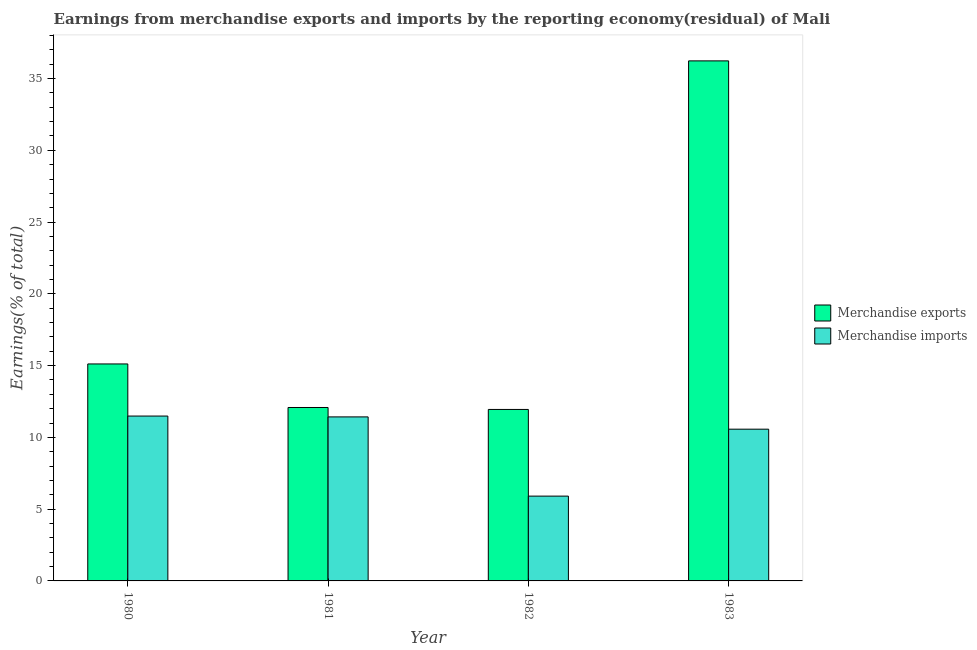How many groups of bars are there?
Make the answer very short. 4. Are the number of bars per tick equal to the number of legend labels?
Make the answer very short. Yes. Are the number of bars on each tick of the X-axis equal?
Your answer should be very brief. Yes. How many bars are there on the 1st tick from the right?
Ensure brevity in your answer.  2. In how many cases, is the number of bars for a given year not equal to the number of legend labels?
Ensure brevity in your answer.  0. What is the earnings from merchandise imports in 1983?
Give a very brief answer. 10.57. Across all years, what is the maximum earnings from merchandise exports?
Give a very brief answer. 36.23. Across all years, what is the minimum earnings from merchandise exports?
Keep it short and to the point. 11.95. In which year was the earnings from merchandise exports maximum?
Your answer should be compact. 1983. In which year was the earnings from merchandise exports minimum?
Provide a succinct answer. 1982. What is the total earnings from merchandise exports in the graph?
Offer a very short reply. 75.38. What is the difference between the earnings from merchandise imports in 1980 and that in 1983?
Offer a very short reply. 0.91. What is the difference between the earnings from merchandise imports in 1982 and the earnings from merchandise exports in 1983?
Your response must be concise. -4.66. What is the average earnings from merchandise imports per year?
Offer a very short reply. 9.85. In the year 1981, what is the difference between the earnings from merchandise exports and earnings from merchandise imports?
Offer a very short reply. 0. What is the ratio of the earnings from merchandise exports in 1980 to that in 1983?
Offer a very short reply. 0.42. Is the earnings from merchandise imports in 1981 less than that in 1983?
Your answer should be very brief. No. What is the difference between the highest and the second highest earnings from merchandise imports?
Provide a succinct answer. 0.06. What is the difference between the highest and the lowest earnings from merchandise exports?
Offer a very short reply. 24.28. In how many years, is the earnings from merchandise exports greater than the average earnings from merchandise exports taken over all years?
Keep it short and to the point. 1. What does the 1st bar from the left in 1980 represents?
Offer a very short reply. Merchandise exports. What does the 2nd bar from the right in 1983 represents?
Offer a very short reply. Merchandise exports. How many bars are there?
Provide a short and direct response. 8. Are all the bars in the graph horizontal?
Your answer should be very brief. No. How many years are there in the graph?
Your answer should be compact. 4. What is the difference between two consecutive major ticks on the Y-axis?
Your answer should be very brief. 5. Are the values on the major ticks of Y-axis written in scientific E-notation?
Provide a succinct answer. No. How are the legend labels stacked?
Provide a short and direct response. Vertical. What is the title of the graph?
Your answer should be compact. Earnings from merchandise exports and imports by the reporting economy(residual) of Mali. Does "Passenger Transport Items" appear as one of the legend labels in the graph?
Your answer should be very brief. No. What is the label or title of the X-axis?
Provide a succinct answer. Year. What is the label or title of the Y-axis?
Offer a terse response. Earnings(% of total). What is the Earnings(% of total) in Merchandise exports in 1980?
Ensure brevity in your answer.  15.12. What is the Earnings(% of total) in Merchandise imports in 1980?
Provide a short and direct response. 11.49. What is the Earnings(% of total) in Merchandise exports in 1981?
Offer a terse response. 12.08. What is the Earnings(% of total) of Merchandise imports in 1981?
Provide a succinct answer. 11.43. What is the Earnings(% of total) in Merchandise exports in 1982?
Offer a very short reply. 11.95. What is the Earnings(% of total) in Merchandise imports in 1982?
Make the answer very short. 5.91. What is the Earnings(% of total) in Merchandise exports in 1983?
Give a very brief answer. 36.23. What is the Earnings(% of total) in Merchandise imports in 1983?
Offer a terse response. 10.57. Across all years, what is the maximum Earnings(% of total) in Merchandise exports?
Offer a very short reply. 36.23. Across all years, what is the maximum Earnings(% of total) in Merchandise imports?
Your answer should be very brief. 11.49. Across all years, what is the minimum Earnings(% of total) in Merchandise exports?
Your response must be concise. 11.95. Across all years, what is the minimum Earnings(% of total) in Merchandise imports?
Your response must be concise. 5.91. What is the total Earnings(% of total) of Merchandise exports in the graph?
Provide a succinct answer. 75.38. What is the total Earnings(% of total) of Merchandise imports in the graph?
Provide a short and direct response. 39.39. What is the difference between the Earnings(% of total) in Merchandise exports in 1980 and that in 1981?
Keep it short and to the point. 3.03. What is the difference between the Earnings(% of total) in Merchandise imports in 1980 and that in 1981?
Your response must be concise. 0.06. What is the difference between the Earnings(% of total) in Merchandise exports in 1980 and that in 1982?
Ensure brevity in your answer.  3.17. What is the difference between the Earnings(% of total) of Merchandise imports in 1980 and that in 1982?
Your answer should be very brief. 5.58. What is the difference between the Earnings(% of total) in Merchandise exports in 1980 and that in 1983?
Your response must be concise. -21.11. What is the difference between the Earnings(% of total) in Merchandise imports in 1980 and that in 1983?
Offer a terse response. 0.91. What is the difference between the Earnings(% of total) of Merchandise exports in 1981 and that in 1982?
Give a very brief answer. 0.14. What is the difference between the Earnings(% of total) in Merchandise imports in 1981 and that in 1982?
Your answer should be compact. 5.52. What is the difference between the Earnings(% of total) of Merchandise exports in 1981 and that in 1983?
Your answer should be very brief. -24.15. What is the difference between the Earnings(% of total) in Merchandise imports in 1981 and that in 1983?
Offer a terse response. 0.86. What is the difference between the Earnings(% of total) in Merchandise exports in 1982 and that in 1983?
Give a very brief answer. -24.28. What is the difference between the Earnings(% of total) of Merchandise imports in 1982 and that in 1983?
Your answer should be very brief. -4.66. What is the difference between the Earnings(% of total) of Merchandise exports in 1980 and the Earnings(% of total) of Merchandise imports in 1981?
Keep it short and to the point. 3.69. What is the difference between the Earnings(% of total) in Merchandise exports in 1980 and the Earnings(% of total) in Merchandise imports in 1982?
Offer a very short reply. 9.21. What is the difference between the Earnings(% of total) of Merchandise exports in 1980 and the Earnings(% of total) of Merchandise imports in 1983?
Provide a short and direct response. 4.54. What is the difference between the Earnings(% of total) in Merchandise exports in 1981 and the Earnings(% of total) in Merchandise imports in 1982?
Keep it short and to the point. 6.17. What is the difference between the Earnings(% of total) in Merchandise exports in 1981 and the Earnings(% of total) in Merchandise imports in 1983?
Your answer should be compact. 1.51. What is the difference between the Earnings(% of total) in Merchandise exports in 1982 and the Earnings(% of total) in Merchandise imports in 1983?
Provide a short and direct response. 1.38. What is the average Earnings(% of total) of Merchandise exports per year?
Give a very brief answer. 18.84. What is the average Earnings(% of total) in Merchandise imports per year?
Your answer should be very brief. 9.85. In the year 1980, what is the difference between the Earnings(% of total) in Merchandise exports and Earnings(% of total) in Merchandise imports?
Ensure brevity in your answer.  3.63. In the year 1981, what is the difference between the Earnings(% of total) of Merchandise exports and Earnings(% of total) of Merchandise imports?
Your response must be concise. 0.66. In the year 1982, what is the difference between the Earnings(% of total) in Merchandise exports and Earnings(% of total) in Merchandise imports?
Your answer should be compact. 6.04. In the year 1983, what is the difference between the Earnings(% of total) of Merchandise exports and Earnings(% of total) of Merchandise imports?
Make the answer very short. 25.66. What is the ratio of the Earnings(% of total) in Merchandise exports in 1980 to that in 1981?
Ensure brevity in your answer.  1.25. What is the ratio of the Earnings(% of total) in Merchandise imports in 1980 to that in 1981?
Ensure brevity in your answer.  1.01. What is the ratio of the Earnings(% of total) in Merchandise exports in 1980 to that in 1982?
Your answer should be very brief. 1.27. What is the ratio of the Earnings(% of total) in Merchandise imports in 1980 to that in 1982?
Ensure brevity in your answer.  1.94. What is the ratio of the Earnings(% of total) in Merchandise exports in 1980 to that in 1983?
Make the answer very short. 0.42. What is the ratio of the Earnings(% of total) of Merchandise imports in 1980 to that in 1983?
Your response must be concise. 1.09. What is the ratio of the Earnings(% of total) in Merchandise exports in 1981 to that in 1982?
Make the answer very short. 1.01. What is the ratio of the Earnings(% of total) of Merchandise imports in 1981 to that in 1982?
Ensure brevity in your answer.  1.93. What is the ratio of the Earnings(% of total) in Merchandise exports in 1981 to that in 1983?
Your answer should be very brief. 0.33. What is the ratio of the Earnings(% of total) in Merchandise imports in 1981 to that in 1983?
Make the answer very short. 1.08. What is the ratio of the Earnings(% of total) in Merchandise exports in 1982 to that in 1983?
Give a very brief answer. 0.33. What is the ratio of the Earnings(% of total) of Merchandise imports in 1982 to that in 1983?
Provide a succinct answer. 0.56. What is the difference between the highest and the second highest Earnings(% of total) of Merchandise exports?
Offer a terse response. 21.11. What is the difference between the highest and the second highest Earnings(% of total) of Merchandise imports?
Provide a short and direct response. 0.06. What is the difference between the highest and the lowest Earnings(% of total) in Merchandise exports?
Provide a short and direct response. 24.28. What is the difference between the highest and the lowest Earnings(% of total) of Merchandise imports?
Give a very brief answer. 5.58. 